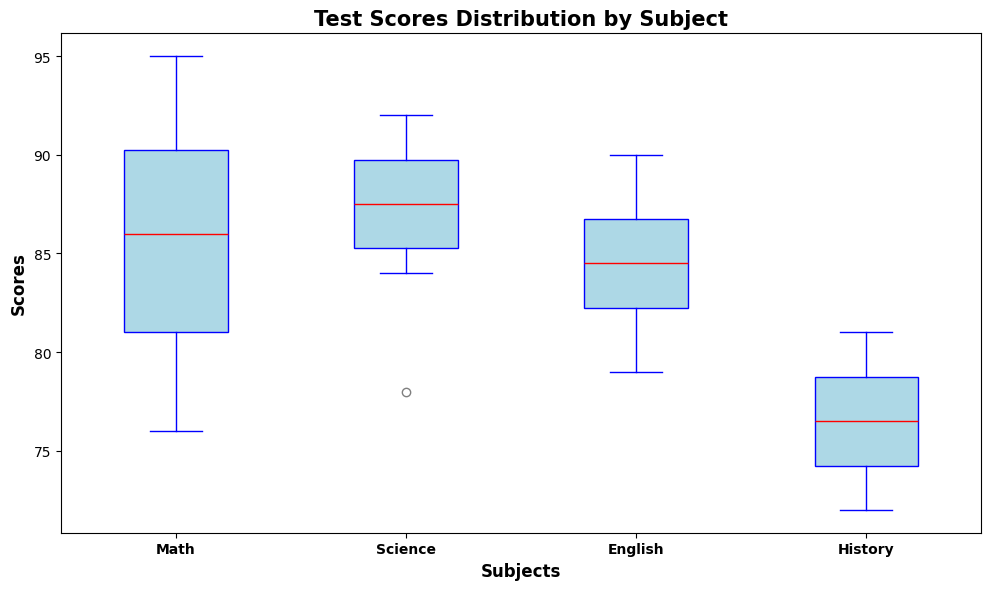What's the median score for Math? The box plot shows the red line inside the box representing the median. For Math, locate this red line and read the corresponding score value.
Answer: 86 Which subject has the highest interquartile range (IQR)? The IQR is the length of the box in the box plot. Compare the lengths of the boxes for Math, Science, English, and History. The longest box corresponds to the subject with the highest IQR.
Answer: Math Which subject has the lowest median score? Look at the position of the red lines inside the boxes for all subjects. The lowest red line corresponds to the subject with the lowest median score.
Answer: History How many subjects have a median score above 85? Identify the red lines (medians) for each subject and count how many are positioned above the score of 85 on the y-axis.
Answer: 3 Which subjects have the same median score? Compare the position of the red lines inside the boxes. Check for subjects where the red lines are aligned horizontally at the same score.
Answer: Science and English What's the range of scores for Science? The range is the difference between the maximum and minimum values represented by the top and bottom whiskers of the box plot for Science.
Answer: 78 to 92 Which subject has the highest maximum score? The highest maximum score is represented by the top whisker across all subjects. Identify the subject with the highest top whisker.
Answer: Math How does the spread of scores for History compare to Math? Compare the length of the whiskers and the size of the boxes. History's whiskers and boxes are narrower, indicating a smaller spread compared to Math.
Answer: Smaller spread Which subject has the most outliers? Outliers are represented by little dots outside the whiskers. Count the number of dots for each subject.
Answer: None What's the difference between the median scores of Math and History? Subtract the median score of History from the median score of Math: (Math median) - (History median).
Answer: 13 